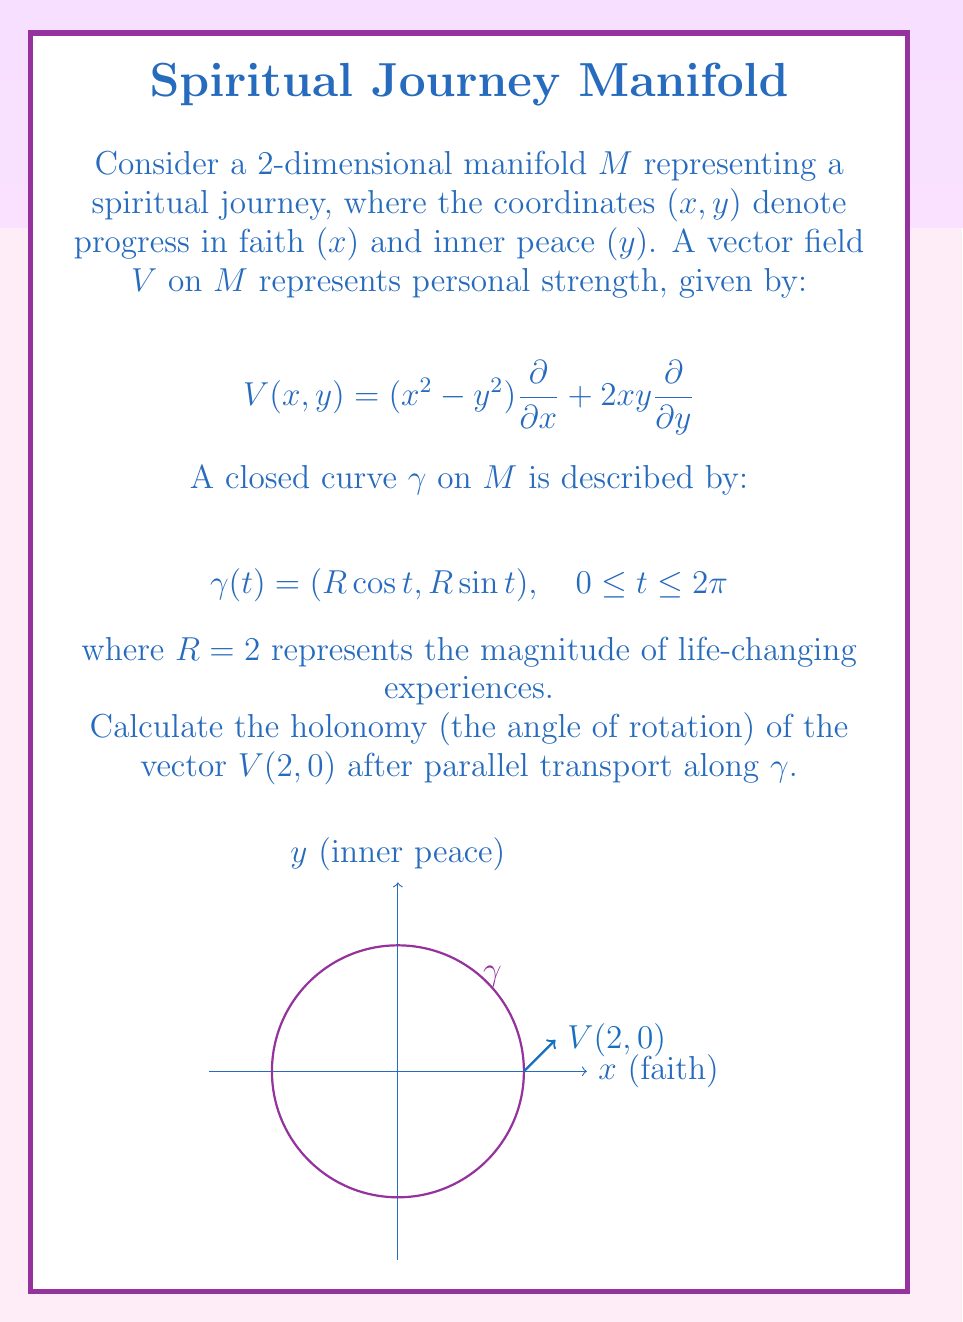Teach me how to tackle this problem. Let's approach this step-by-step:

1) The Riemannian curvature tensor on a 2-dimensional manifold is given by:

   $$R_{1212} = K(x,y)g_{11}g_{22}$$

   where $K(x,y)$ is the Gaussian curvature and $g_{ij}$ are the metric components.

2) For this manifold, we assume a simple metric $g_{ij} = \delta_{ij}$ (Euclidean metric).

3) The Gaussian curvature can be calculated from the vector field:

   $$K = \frac{1}{2}\left(\frac{\partial^2 V^2}{\partial x^2} + \frac{\partial^2 V^1}{\partial y^2}\right) = 2$$

4) The holonomy for parallel transport around a closed curve is given by:

   $$\theta = \int_{\gamma} K dA = K \cdot \text{Area}(\gamma)$$

5) The area enclosed by $\gamma$ is:

   $$\text{Area}(\gamma) = \pi R^2 = \pi \cdot 2^2 = 4\pi$$

6) Therefore, the holonomy is:

   $$\theta = K \cdot \text{Area}(\gamma) = 2 \cdot 4\pi = 8\pi$$

7) This represents a total rotation of $4$ complete turns (since $2\pi$ is one complete rotation).
Answer: $8\pi$ radians 